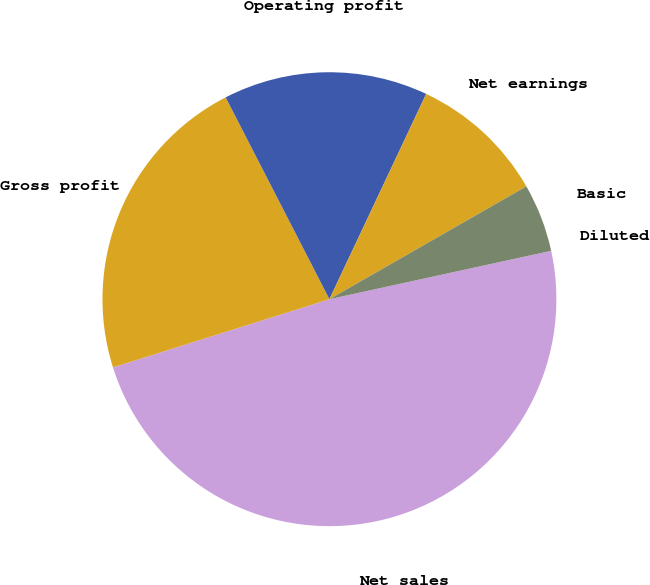Convert chart to OTSL. <chart><loc_0><loc_0><loc_500><loc_500><pie_chart><fcel>Net sales<fcel>Gross profit<fcel>Operating profit<fcel>Net earnings<fcel>Basic<fcel>Diluted<nl><fcel>48.56%<fcel>22.3%<fcel>14.57%<fcel>9.71%<fcel>4.86%<fcel>0.0%<nl></chart> 